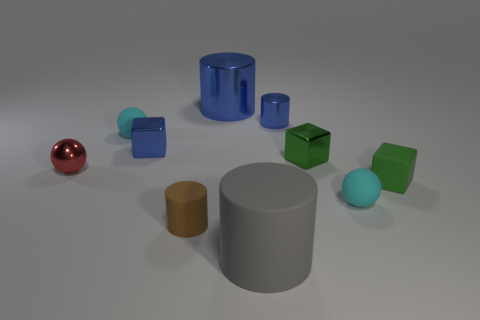Subtract all cylinders. How many objects are left? 6 Add 7 gray rubber things. How many gray rubber things exist? 8 Subtract 0 yellow cylinders. How many objects are left? 10 Subtract all cyan rubber spheres. Subtract all blue shiny objects. How many objects are left? 5 Add 1 large gray matte cylinders. How many large gray matte cylinders are left? 2 